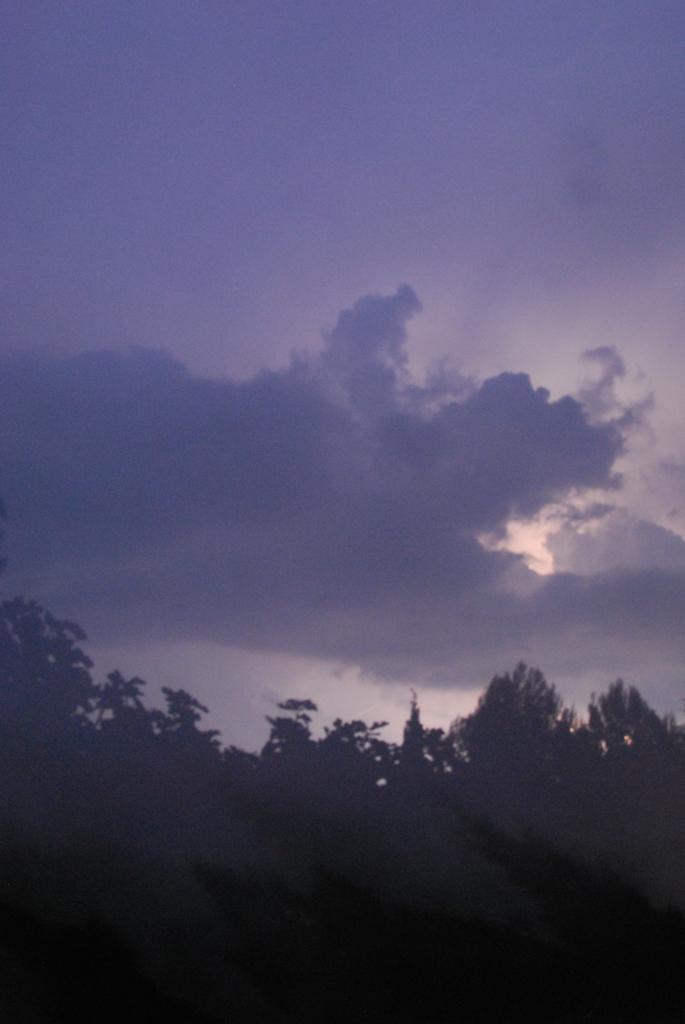Can you describe this image briefly? In this picture I can see some trees and cloudy sky. 